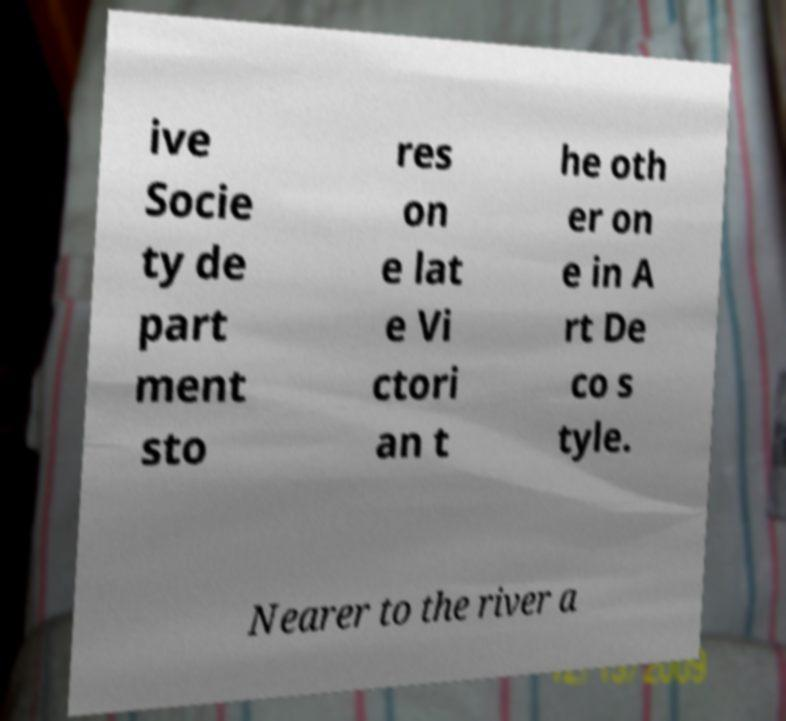Can you read and provide the text displayed in the image?This photo seems to have some interesting text. Can you extract and type it out for me? ive Socie ty de part ment sto res on e lat e Vi ctori an t he oth er on e in A rt De co s tyle. Nearer to the river a 